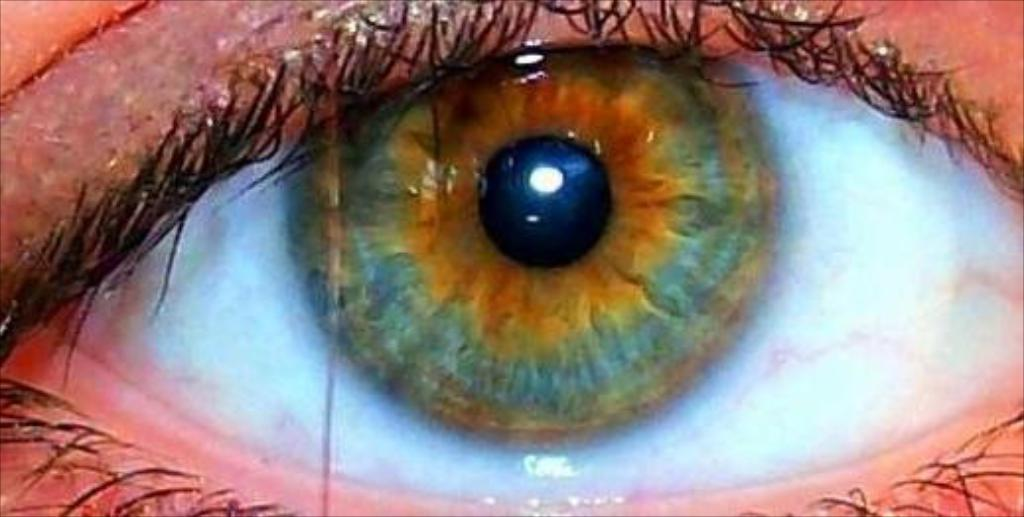What is the main subject of the image? The main subject of the image is a person's eye. What part of the eye is visible in the image? The retina is visible in the eye. What is visible around the eye in the image? The skin around the eye and the eyebrows above the eye are visible. Where is the drawer located in the image? There is no drawer present in the image; it features a person's eye. What type of harmony can be seen in the image? The image does not depict harmony; it is a close-up of a person's eye. 